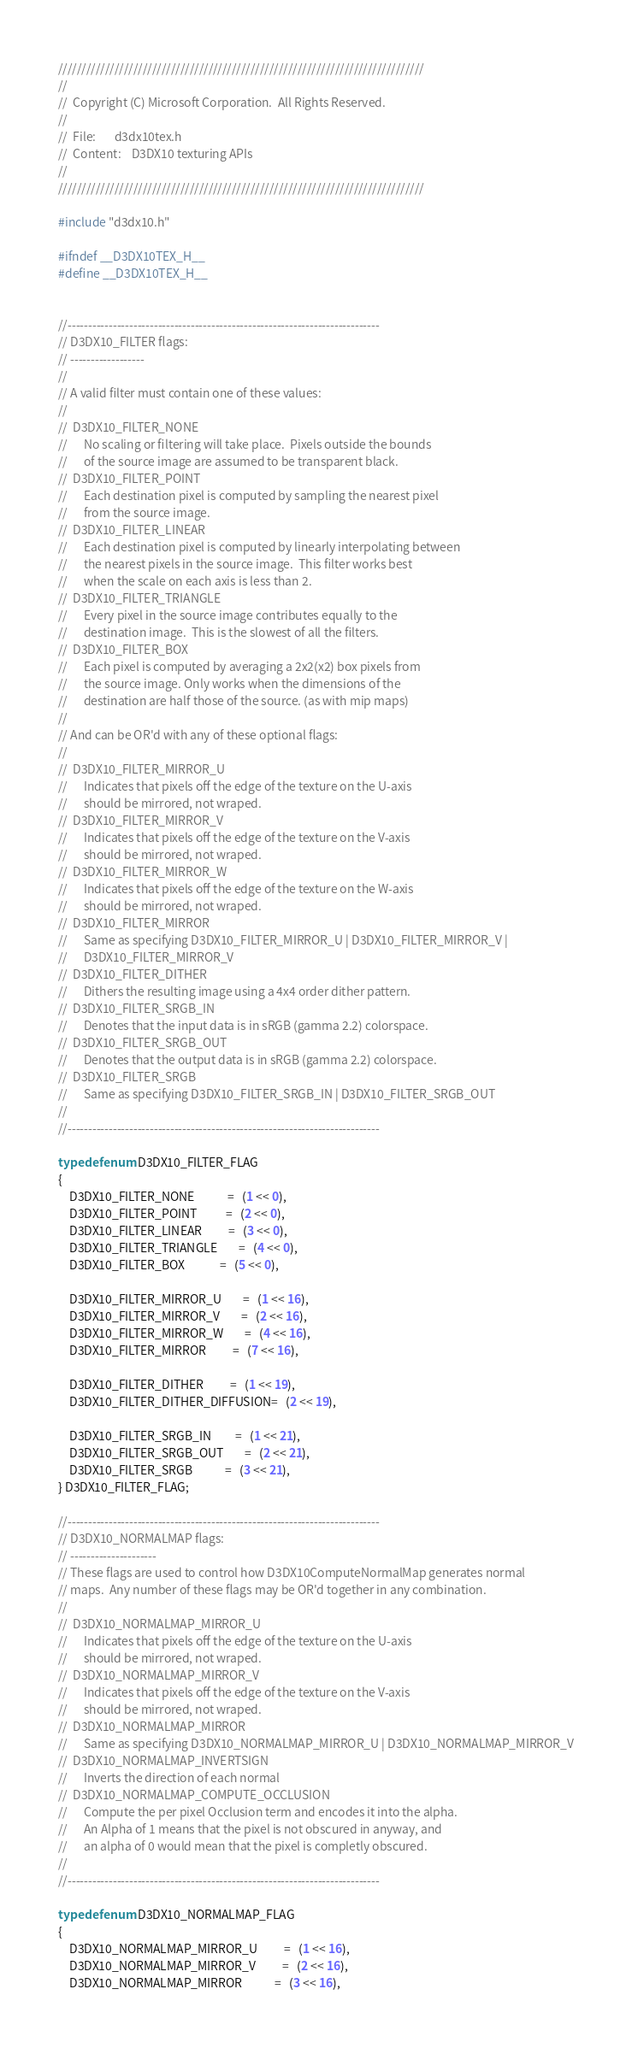<code> <loc_0><loc_0><loc_500><loc_500><_C_>//////////////////////////////////////////////////////////////////////////////
//
//  Copyright (C) Microsoft Corporation.  All Rights Reserved.
//
//  File:       d3dx10tex.h
//  Content:    D3DX10 texturing APIs
//
//////////////////////////////////////////////////////////////////////////////

#include "d3dx10.h"

#ifndef __D3DX10TEX_H__
#define __D3DX10TEX_H__


//----------------------------------------------------------------------------
// D3DX10_FILTER flags:
// ------------------
//
// A valid filter must contain one of these values:
//
//  D3DX10_FILTER_NONE
//      No scaling or filtering will take place.  Pixels outside the bounds
//      of the source image are assumed to be transparent black.
//  D3DX10_FILTER_POINT
//      Each destination pixel is computed by sampling the nearest pixel
//      from the source image.
//  D3DX10_FILTER_LINEAR
//      Each destination pixel is computed by linearly interpolating between
//      the nearest pixels in the source image.  This filter works best 
//      when the scale on each axis is less than 2.
//  D3DX10_FILTER_TRIANGLE
//      Every pixel in the source image contributes equally to the
//      destination image.  This is the slowest of all the filters.
//  D3DX10_FILTER_BOX
//      Each pixel is computed by averaging a 2x2(x2) box pixels from 
//      the source image. Only works when the dimensions of the 
//      destination are half those of the source. (as with mip maps)
//
// And can be OR'd with any of these optional flags:
//
//  D3DX10_FILTER_MIRROR_U
//      Indicates that pixels off the edge of the texture on the U-axis
//      should be mirrored, not wraped.
//  D3DX10_FILTER_MIRROR_V
//      Indicates that pixels off the edge of the texture on the V-axis
//      should be mirrored, not wraped.
//  D3DX10_FILTER_MIRROR_W
//      Indicates that pixels off the edge of the texture on the W-axis
//      should be mirrored, not wraped.
//  D3DX10_FILTER_MIRROR
//      Same as specifying D3DX10_FILTER_MIRROR_U | D3DX10_FILTER_MIRROR_V |
//      D3DX10_FILTER_MIRROR_V
//  D3DX10_FILTER_DITHER
//      Dithers the resulting image using a 4x4 order dither pattern.
//  D3DX10_FILTER_SRGB_IN
//      Denotes that the input data is in sRGB (gamma 2.2) colorspace.
//  D3DX10_FILTER_SRGB_OUT
//      Denotes that the output data is in sRGB (gamma 2.2) colorspace.
//  D3DX10_FILTER_SRGB
//      Same as specifying D3DX10_FILTER_SRGB_IN | D3DX10_FILTER_SRGB_OUT
//
//----------------------------------------------------------------------------

typedef enum D3DX10_FILTER_FLAG
{
    D3DX10_FILTER_NONE            =   (1 << 0),
    D3DX10_FILTER_POINT           =   (2 << 0),
    D3DX10_FILTER_LINEAR          =   (3 << 0),
    D3DX10_FILTER_TRIANGLE        =   (4 << 0),
    D3DX10_FILTER_BOX             =   (5 << 0),

    D3DX10_FILTER_MIRROR_U        =   (1 << 16),
    D3DX10_FILTER_MIRROR_V        =   (2 << 16),
    D3DX10_FILTER_MIRROR_W        =   (4 << 16),
    D3DX10_FILTER_MIRROR          =   (7 << 16),

    D3DX10_FILTER_DITHER          =   (1 << 19),
    D3DX10_FILTER_DITHER_DIFFUSION=   (2 << 19),

    D3DX10_FILTER_SRGB_IN         =   (1 << 21),
    D3DX10_FILTER_SRGB_OUT        =   (2 << 21),
    D3DX10_FILTER_SRGB            =   (3 << 21),
} D3DX10_FILTER_FLAG;

//----------------------------------------------------------------------------
// D3DX10_NORMALMAP flags:
// ---------------------
// These flags are used to control how D3DX10ComputeNormalMap generates normal
// maps.  Any number of these flags may be OR'd together in any combination.
//
//  D3DX10_NORMALMAP_MIRROR_U
//      Indicates that pixels off the edge of the texture on the U-axis
//      should be mirrored, not wraped.
//  D3DX10_NORMALMAP_MIRROR_V
//      Indicates that pixels off the edge of the texture on the V-axis
//      should be mirrored, not wraped.
//  D3DX10_NORMALMAP_MIRROR
//      Same as specifying D3DX10_NORMALMAP_MIRROR_U | D3DX10_NORMALMAP_MIRROR_V
//  D3DX10_NORMALMAP_INVERTSIGN
//      Inverts the direction of each normal 
//  D3DX10_NORMALMAP_COMPUTE_OCCLUSION
//      Compute the per pixel Occlusion term and encodes it into the alpha.
//      An Alpha of 1 means that the pixel is not obscured in anyway, and
//      an alpha of 0 would mean that the pixel is completly obscured.
//
//----------------------------------------------------------------------------

typedef enum D3DX10_NORMALMAP_FLAG
{
    D3DX10_NORMALMAP_MIRROR_U          =   (1 << 16),
    D3DX10_NORMALMAP_MIRROR_V          =   (2 << 16),
    D3DX10_NORMALMAP_MIRROR            =   (3 << 16),</code> 